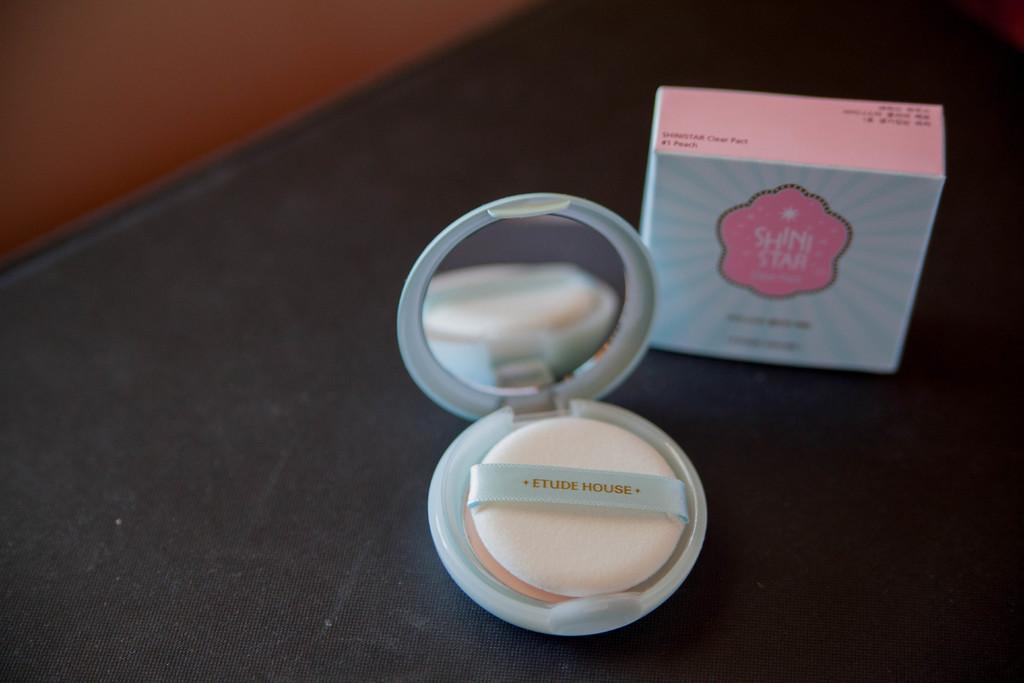Please provide a concise description of this image. In this image we can see a box and compact powder on a black color platform. 